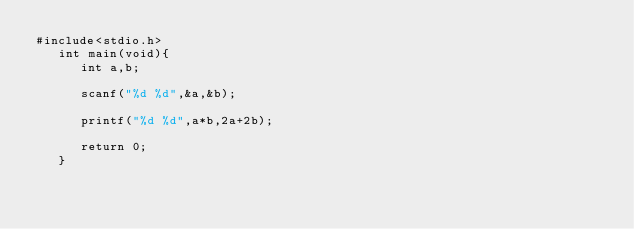Convert code to text. <code><loc_0><loc_0><loc_500><loc_500><_C_>#include<stdio.h>
   int main(void){
      int a,b;

      scanf("%d %d",&a,&b);

      printf("%d %d",a*b,2a+2b);

      return 0;
   }
</code> 